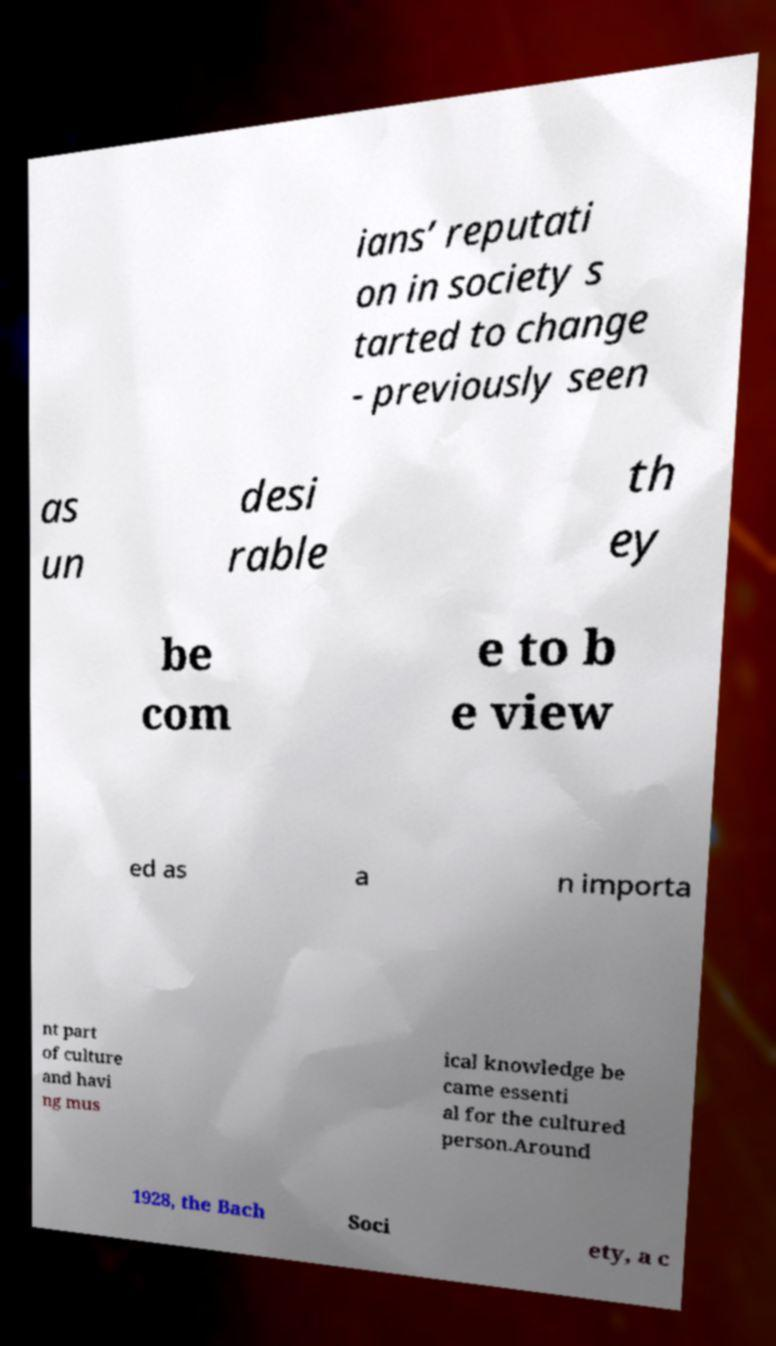Could you assist in decoding the text presented in this image and type it out clearly? ians’ reputati on in society s tarted to change - previously seen as un desi rable th ey be com e to b e view ed as a n importa nt part of culture and havi ng mus ical knowledge be came essenti al for the cultured person.Around 1928, the Bach Soci ety, a c 